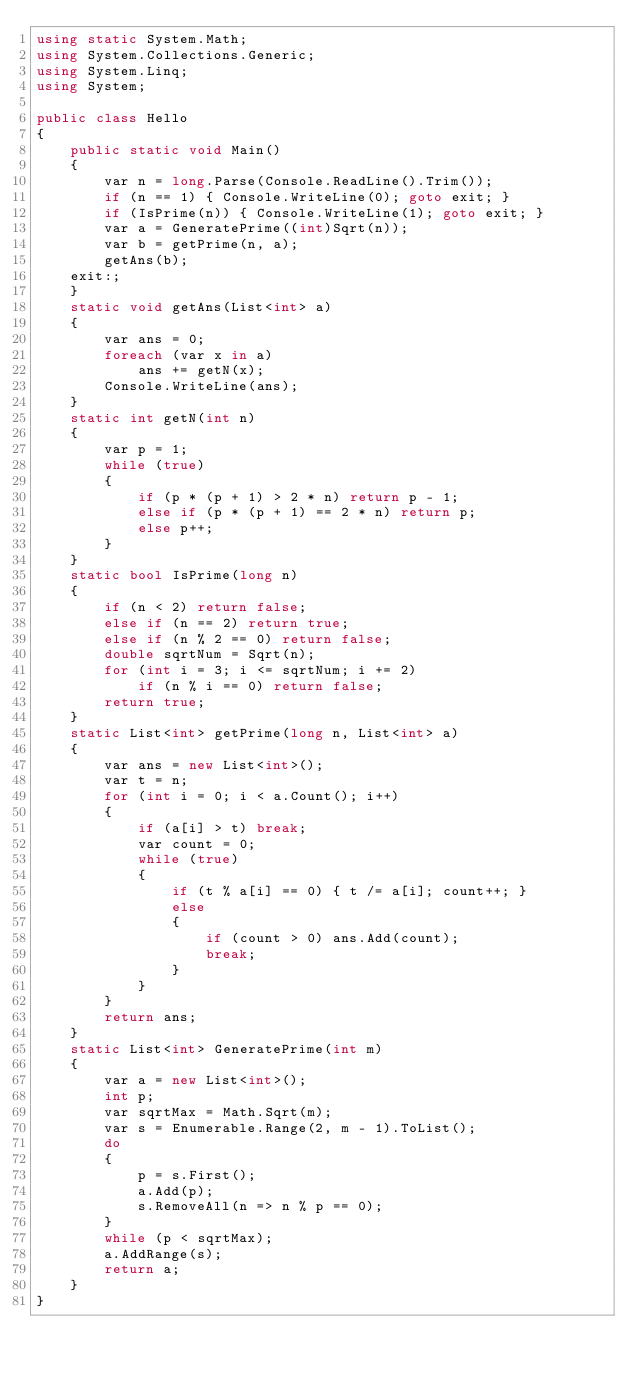<code> <loc_0><loc_0><loc_500><loc_500><_C#_>using static System.Math;
using System.Collections.Generic;
using System.Linq;
using System;

public class Hello
{
    public static void Main()
    {
        var n = long.Parse(Console.ReadLine().Trim());
        if (n == 1) { Console.WriteLine(0); goto exit; }
        if (IsPrime(n)) { Console.WriteLine(1); goto exit; }
        var a = GeneratePrime((int)Sqrt(n));
        var b = getPrime(n, a);
        getAns(b);
    exit:;
    }
    static void getAns(List<int> a)
    {
        var ans = 0;
        foreach (var x in a)
            ans += getN(x);
        Console.WriteLine(ans);
    }
    static int getN(int n)
    {
        var p = 1;
        while (true)
        {
            if (p * (p + 1) > 2 * n) return p - 1;
            else if (p * (p + 1) == 2 * n) return p;
            else p++;
        }
    }
    static bool IsPrime(long n)
    {
        if (n < 2) return false;
        else if (n == 2) return true;
        else if (n % 2 == 0) return false;
        double sqrtNum = Sqrt(n);
        for (int i = 3; i <= sqrtNum; i += 2)
            if (n % i == 0) return false;
        return true;
    }
    static List<int> getPrime(long n, List<int> a)
    {
        var ans = new List<int>();
        var t = n;
        for (int i = 0; i < a.Count(); i++)
        {
            if (a[i] > t) break;
            var count = 0;
            while (true)
            {
                if (t % a[i] == 0) { t /= a[i]; count++; }
                else
                {
                    if (count > 0) ans.Add(count);
                    break;
                }
            }
        }
        return ans;
    }
    static List<int> GeneratePrime(int m)
    {
        var a = new List<int>();
        int p;
        var sqrtMax = Math.Sqrt(m);
        var s = Enumerable.Range(2, m - 1).ToList();
        do
        {
            p = s.First();
            a.Add(p);
            s.RemoveAll(n => n % p == 0);
        }
        while (p < sqrtMax);
        a.AddRange(s);
        return a;
    }
}</code> 